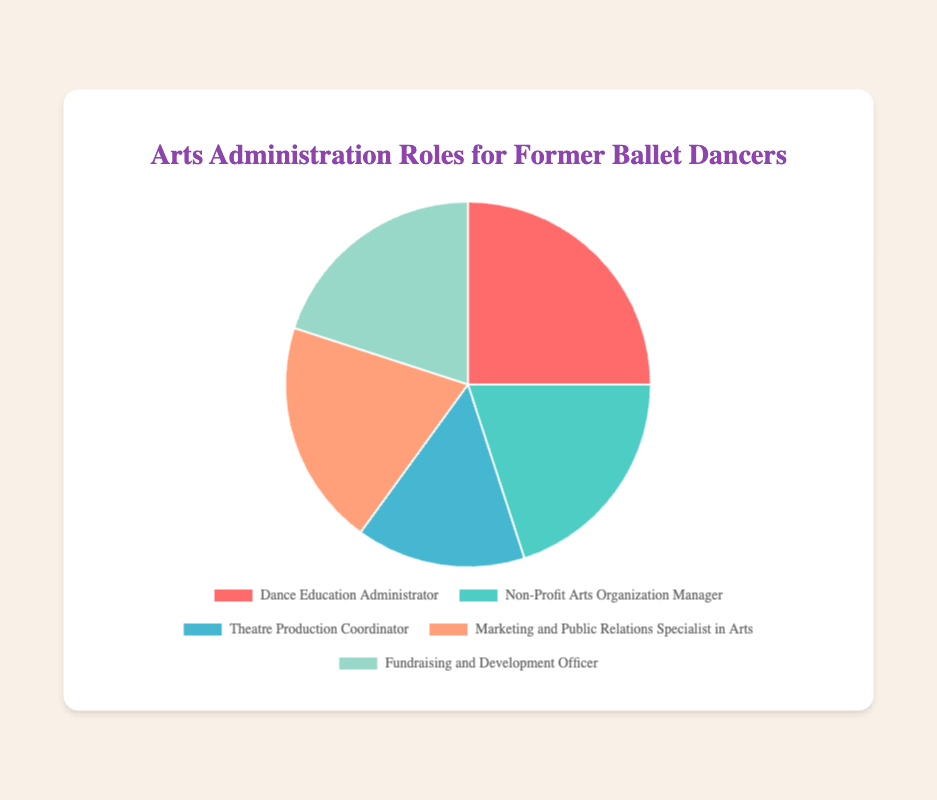What is the percentage of Dance Education Administrators? The figure shows a pie chart with different roles and their corresponding percentages. Dance Education Administrator has a segment labeled with 25%.
Answer: 25% Which roles have the same percentage of representation? By observing the pie chart, it can be seen that Non-Profit Arts Organization Manager, Marketing and Public Relations Specialist in Arts, and Fundraising and Development Officer each have a segment labeled with 20%.
Answer: Non-Profit Arts Organization Manager, Marketing and Public Relations Specialist in Arts, Fundraising and Development Officer What is the total percentage of roles related to non-profit arts and fundraising combined? To find the total percentage, add the percentages for Non-Profit Arts Organization Manager (20%) and Fundraising and Development Officer (20%). The result is 20% + 20% = 40%.
Answer: 40% Which role has the smallest percentage of representation? By observing the pie chart, the smallest segment corresponds to Theatre Production Coordinator, labeled with 15%.
Answer: Theatre Production Coordinator How does the percentage of Dance Education Administrators compare to that of Theatre Production Coordinators? To compare, subtract the percentage of Theatre Production Coordinators (15%) from that of Dance Education Administrators (25%). The result is 25% - 15% = 10%. Dance Education Administrators have a 10% higher representation.
Answer: Dance Education Administrators have 10% more What are the total percentages covered by all roles in the chart? Sum up the percentages of all roles: 25% (Dance Education Administrator) + 20% (Non-Profit Arts Organization Manager) + 15% (Theatre Production Coordinator) + 20% (Marketing and Public Relations Specialist in Arts) + 20% (Fundraising and Development Officer). This equals 25% + 20% + 15% + 20% + 20% = 100%.
Answer: 100% Which color represents the segment for Marketing and Public Relations Specialist in Arts? The pie chart uses colors to represent different roles. The segment for Marketing and Public Relations Specialist in Arts is labeled with an orange color.
Answer: Orange If we combine the roles of Theatre Production Coordinator and Marketing and Public Relations Specialist in Arts, what is their combined percentage? To find the combined percentage, add the percentages of Theatre Production Coordinator (15%) and Marketing and Public Relations Specialist in Arts (20%). The result is 15% + 20% = 35%.
Answer: 35% What is the difference in representation between the most and least popular roles? To find the difference, subtract the percentage of the least popular role (Theatre Production Coordinator, 15%) from that of the most popular role (Dance Education Administrator, 25%). The result is 25% - 15% = 10%.
Answer: 10% 